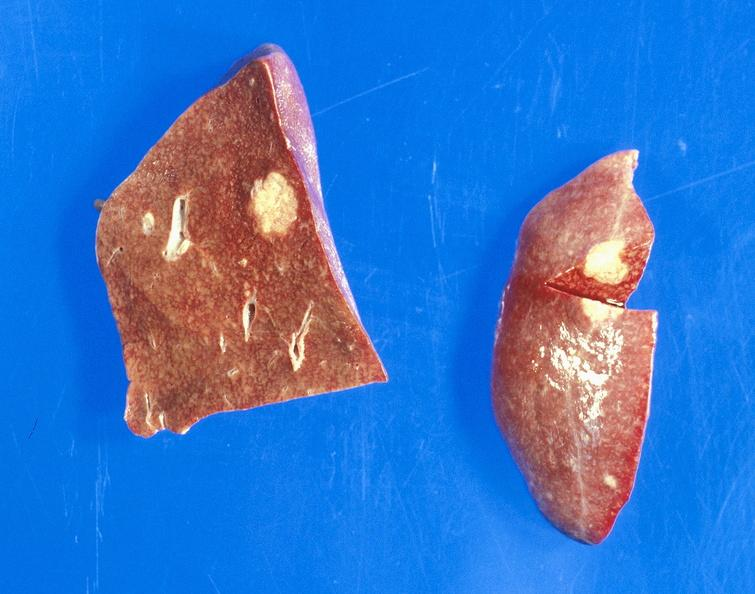does this image show bronchiogenic carcinoma, smoker, metastases?
Answer the question using a single word or phrase. Yes 